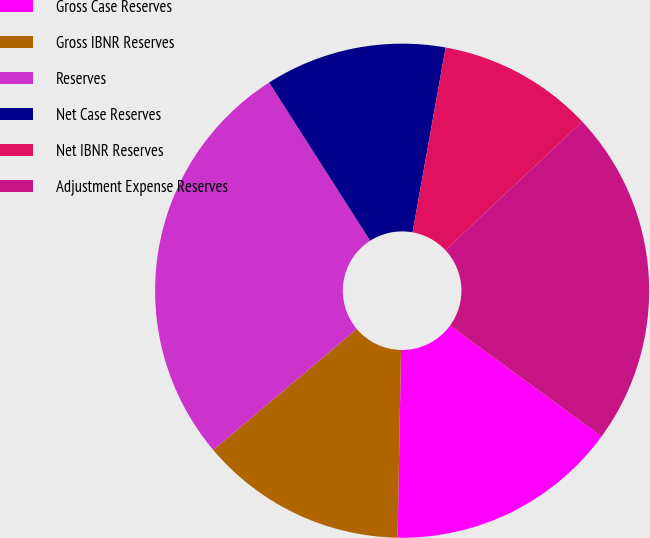<chart> <loc_0><loc_0><loc_500><loc_500><pie_chart><fcel>Gross Case Reserves<fcel>Gross IBNR Reserves<fcel>Reserves<fcel>Net Case Reserves<fcel>Net IBNR Reserves<fcel>Adjustment Expense Reserves<nl><fcel>15.25%<fcel>13.56%<fcel>27.1%<fcel>11.87%<fcel>10.18%<fcel>22.04%<nl></chart> 